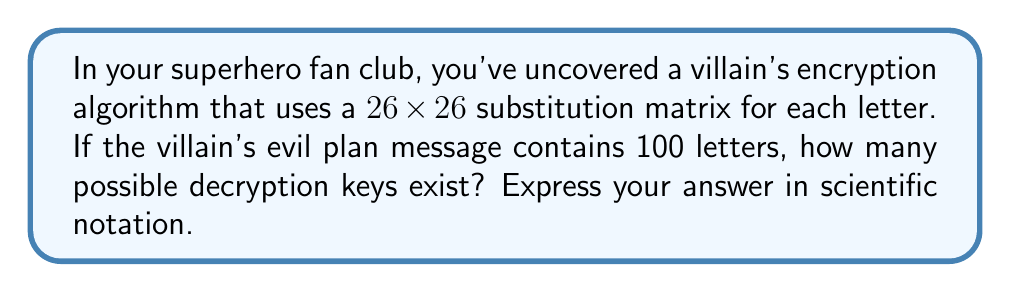Can you answer this question? Let's approach this step-by-step:

1) The encryption uses a $26 \times 26$ substitution matrix. This means for each letter in the alphabet, there are 26 possible substitutions.

2) For the first letter in the matrix, we have 26 choices.

3) For the second letter, we have 25 choices (as we can't use the letter we used for the first substitution).

4) This pattern continues, so we have:
   $26 \times 25 \times 24 \times ... \times 2 \times 1$

5) This is actually the definition of 26 factorial, denoted as $26!$

6) The number of letters in the message (100) doesn't affect the number of possible keys, as the same substitution matrix is used for the entire message.

7) Calculate $26!$:
   $$26! = 4.0329146 \times 10^{26}$$

8) Express this in scientific notation, rounding to 3 significant figures:
   $$4.03 \times 10^{26}$$
Answer: $4.03 \times 10^{26}$ 